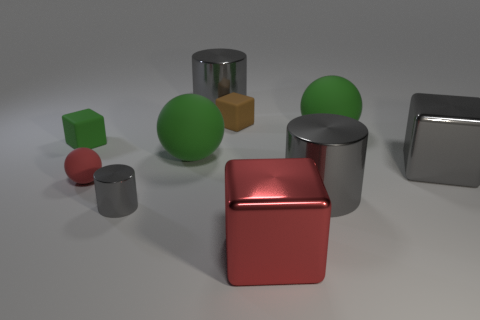Subtract all green spheres. How many were subtracted if there are1green spheres left? 1 Subtract all cylinders. How many objects are left? 7 Subtract 1 gray blocks. How many objects are left? 9 Subtract all big brown cubes. Subtract all small cylinders. How many objects are left? 9 Add 9 big red objects. How many big red objects are left? 10 Add 2 large gray cylinders. How many large gray cylinders exist? 4 